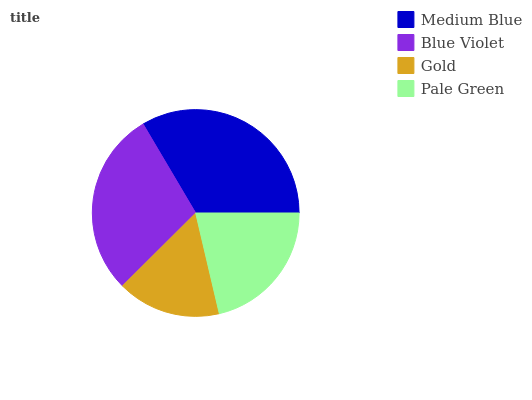Is Gold the minimum?
Answer yes or no. Yes. Is Medium Blue the maximum?
Answer yes or no. Yes. Is Blue Violet the minimum?
Answer yes or no. No. Is Blue Violet the maximum?
Answer yes or no. No. Is Medium Blue greater than Blue Violet?
Answer yes or no. Yes. Is Blue Violet less than Medium Blue?
Answer yes or no. Yes. Is Blue Violet greater than Medium Blue?
Answer yes or no. No. Is Medium Blue less than Blue Violet?
Answer yes or no. No. Is Blue Violet the high median?
Answer yes or no. Yes. Is Pale Green the low median?
Answer yes or no. Yes. Is Gold the high median?
Answer yes or no. No. Is Blue Violet the low median?
Answer yes or no. No. 